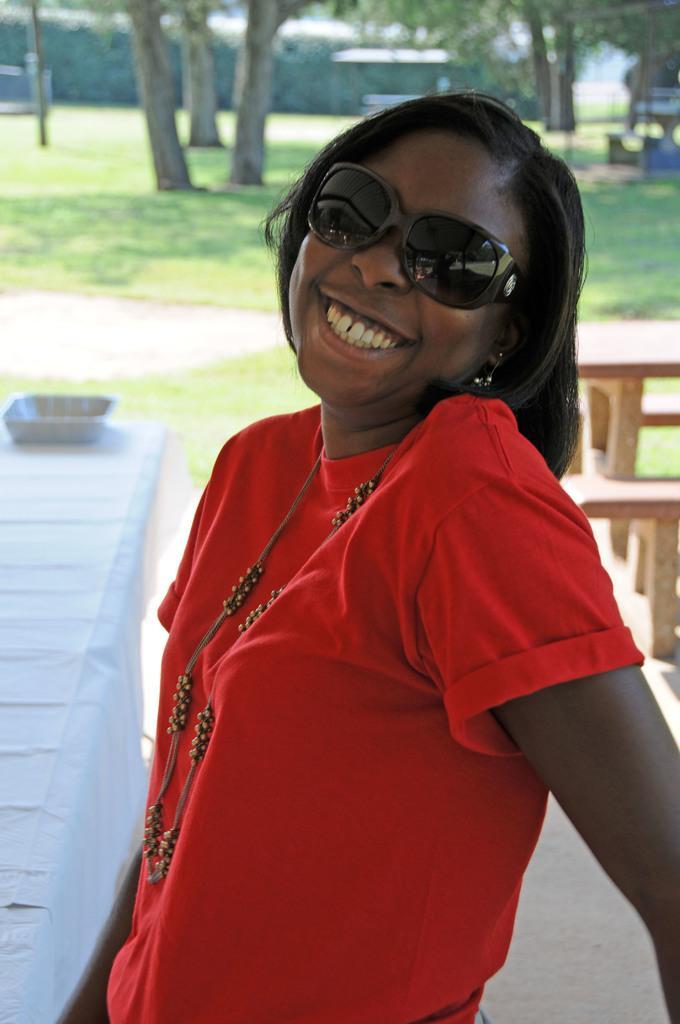Please provide a concise description of this image. In the center of the image we can see one woman is standing and she is smiling. And we can see she is wearing glasses and she is in a red color t shirt. In the background, we can see trees, grass, tables, one cloth, benches, one basket and a few other objects. 